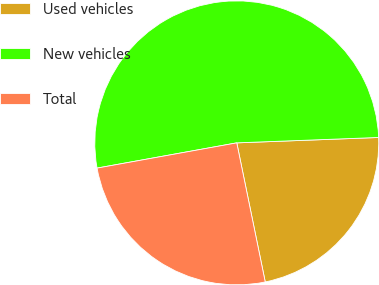Convert chart. <chart><loc_0><loc_0><loc_500><loc_500><pie_chart><fcel>Used vehicles<fcel>New vehicles<fcel>Total<nl><fcel>22.39%<fcel>52.24%<fcel>25.37%<nl></chart> 